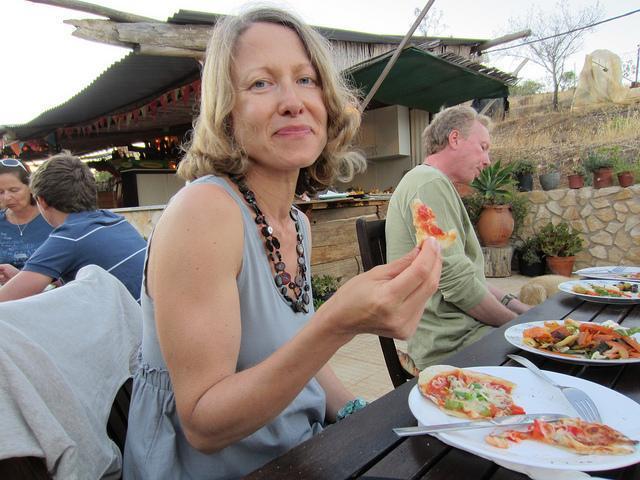How many blue shirts are in the photo?
Give a very brief answer. 2. How many people are in the photo?
Give a very brief answer. 4. How many chairs can you see?
Give a very brief answer. 2. How many yellow umbrellas are in this photo?
Give a very brief answer. 0. 